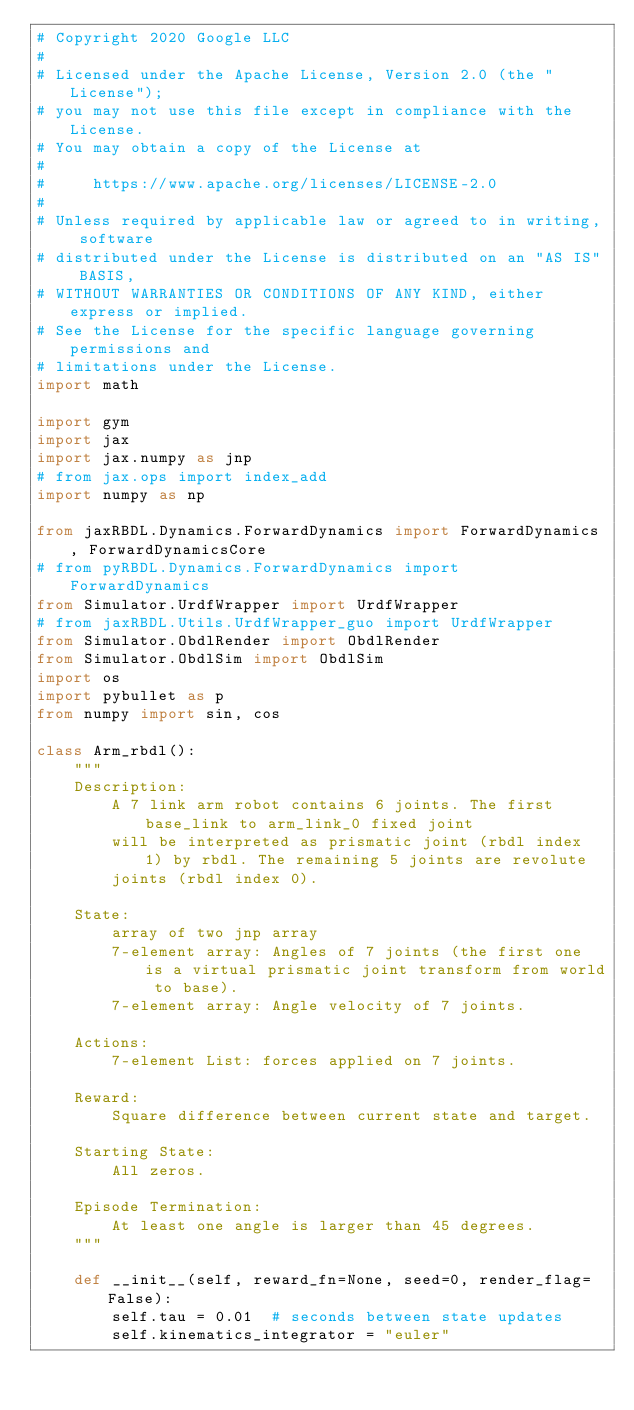Convert code to text. <code><loc_0><loc_0><loc_500><loc_500><_Python_># Copyright 2020 Google LLC
#
# Licensed under the Apache License, Version 2.0 (the "License");
# you may not use this file except in compliance with the License.
# You may obtain a copy of the License at
#
#     https://www.apache.org/licenses/LICENSE-2.0
#
# Unless required by applicable law or agreed to in writing, software
# distributed under the License is distributed on an "AS IS" BASIS,
# WITHOUT WARRANTIES OR CONDITIONS OF ANY KIND, either express or implied.
# See the License for the specific language governing permissions and
# limitations under the License.
import math

import gym
import jax
import jax.numpy as jnp
# from jax.ops import index_add
import numpy as np

from jaxRBDL.Dynamics.ForwardDynamics import ForwardDynamics, ForwardDynamicsCore
# from pyRBDL.Dynamics.ForwardDynamics import ForwardDynamics
from Simulator.UrdfWrapper import UrdfWrapper
# from jaxRBDL.Utils.UrdfWrapper_guo import UrdfWrapper
from Simulator.ObdlRender import ObdlRender
from Simulator.ObdlSim import ObdlSim
import os
import pybullet as p
from numpy import sin, cos

class Arm_rbdl():
    """
    Description:
        A 7 link arm robot contains 6 joints. The first base_link to arm_link_0 fixed joint 
        will be interpreted as prismatic joint (rbdl index 1) by rbdl. The remaining 5 joints are revolute
        joints (rbdl index 0).

    State:
        array of two jnp array       
        7-element array: Angles of 7 joints (the first one is a virtual prismatic joint transform from world to base).
        7-element array: Angle velocity of 7 joints.

    Actions:
        7-element List: forces applied on 7 joints.

    Reward:
        Square difference between current state and target. 

    Starting State:
        All zeros.

    Episode Termination:
        At least one angle is larger than 45 degrees.
    """

    def __init__(self, reward_fn=None, seed=0, render_flag=False):
        self.tau = 0.01  # seconds between state updates
        self.kinematics_integrator = "euler"</code> 